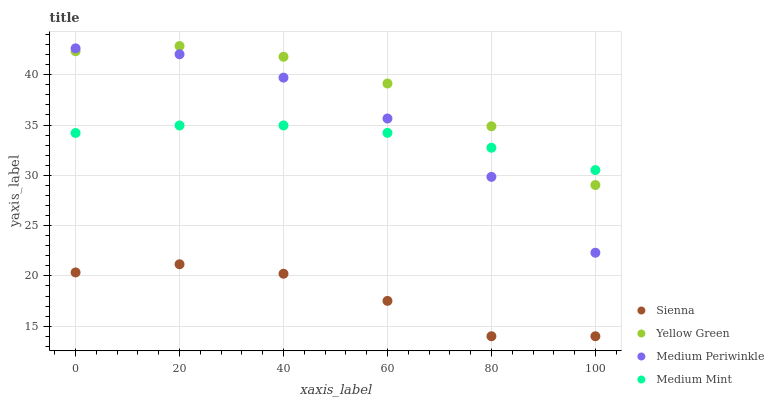Does Sienna have the minimum area under the curve?
Answer yes or no. Yes. Does Yellow Green have the maximum area under the curve?
Answer yes or no. Yes. Does Medium Mint have the minimum area under the curve?
Answer yes or no. No. Does Medium Mint have the maximum area under the curve?
Answer yes or no. No. Is Medium Mint the smoothest?
Answer yes or no. Yes. Is Sienna the roughest?
Answer yes or no. Yes. Is Medium Periwinkle the smoothest?
Answer yes or no. No. Is Medium Periwinkle the roughest?
Answer yes or no. No. Does Sienna have the lowest value?
Answer yes or no. Yes. Does Medium Periwinkle have the lowest value?
Answer yes or no. No. Does Yellow Green have the highest value?
Answer yes or no. Yes. Does Medium Mint have the highest value?
Answer yes or no. No. Is Sienna less than Yellow Green?
Answer yes or no. Yes. Is Medium Mint greater than Sienna?
Answer yes or no. Yes. Does Medium Mint intersect Medium Periwinkle?
Answer yes or no. Yes. Is Medium Mint less than Medium Periwinkle?
Answer yes or no. No. Is Medium Mint greater than Medium Periwinkle?
Answer yes or no. No. Does Sienna intersect Yellow Green?
Answer yes or no. No. 